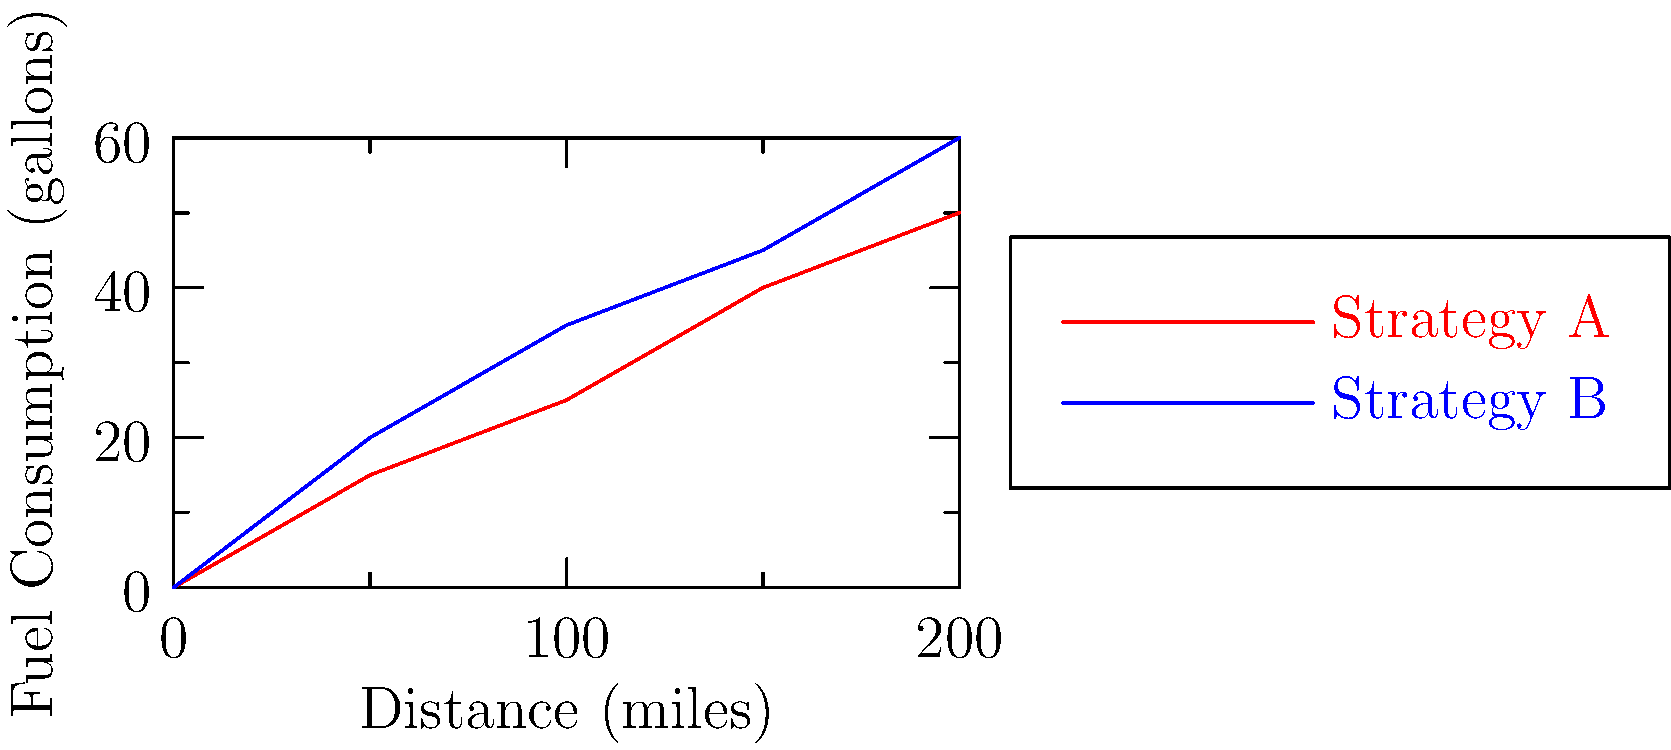As a race car driver, you're analyzing two different fuel consumption strategies for your upcoming 200-mile race. The graph shows the fuel consumption rates for Strategy A (red) and Strategy B (blue). If your car's fuel tank capacity is 55 gallons, which strategy would allow you to complete the race without refueling, and how many gallons of fuel would you have left at the finish line? Let's analyze this step-by-step:

1. First, we need to determine the fuel consumption for each strategy at the 200-mile mark:
   - Strategy A (red line): 50 gallons
   - Strategy B (blue line): 60 gallons

2. Compare these values to the fuel tank capacity (55 gallons):
   - Strategy A: 50 gallons < 55 gallons (tank capacity)
   - Strategy B: 60 gallons > 55 gallons (tank capacity)

3. Strategy B would require more fuel than the tank can hold, so it's not feasible without refueling.

4. Strategy A, however, uses less fuel than the tank capacity, so it would allow completion of the race without refueling.

5. To calculate the remaining fuel with Strategy A:
   Remaining fuel = Tank capacity - Fuel consumed
   $$55 \text{ gallons} - 50 \text{ gallons} = 5 \text{ gallons}$$

Therefore, Strategy A would allow you to complete the race without refueling, with 5 gallons of fuel remaining at the finish line.
Answer: Strategy A, 5 gallons remaining 